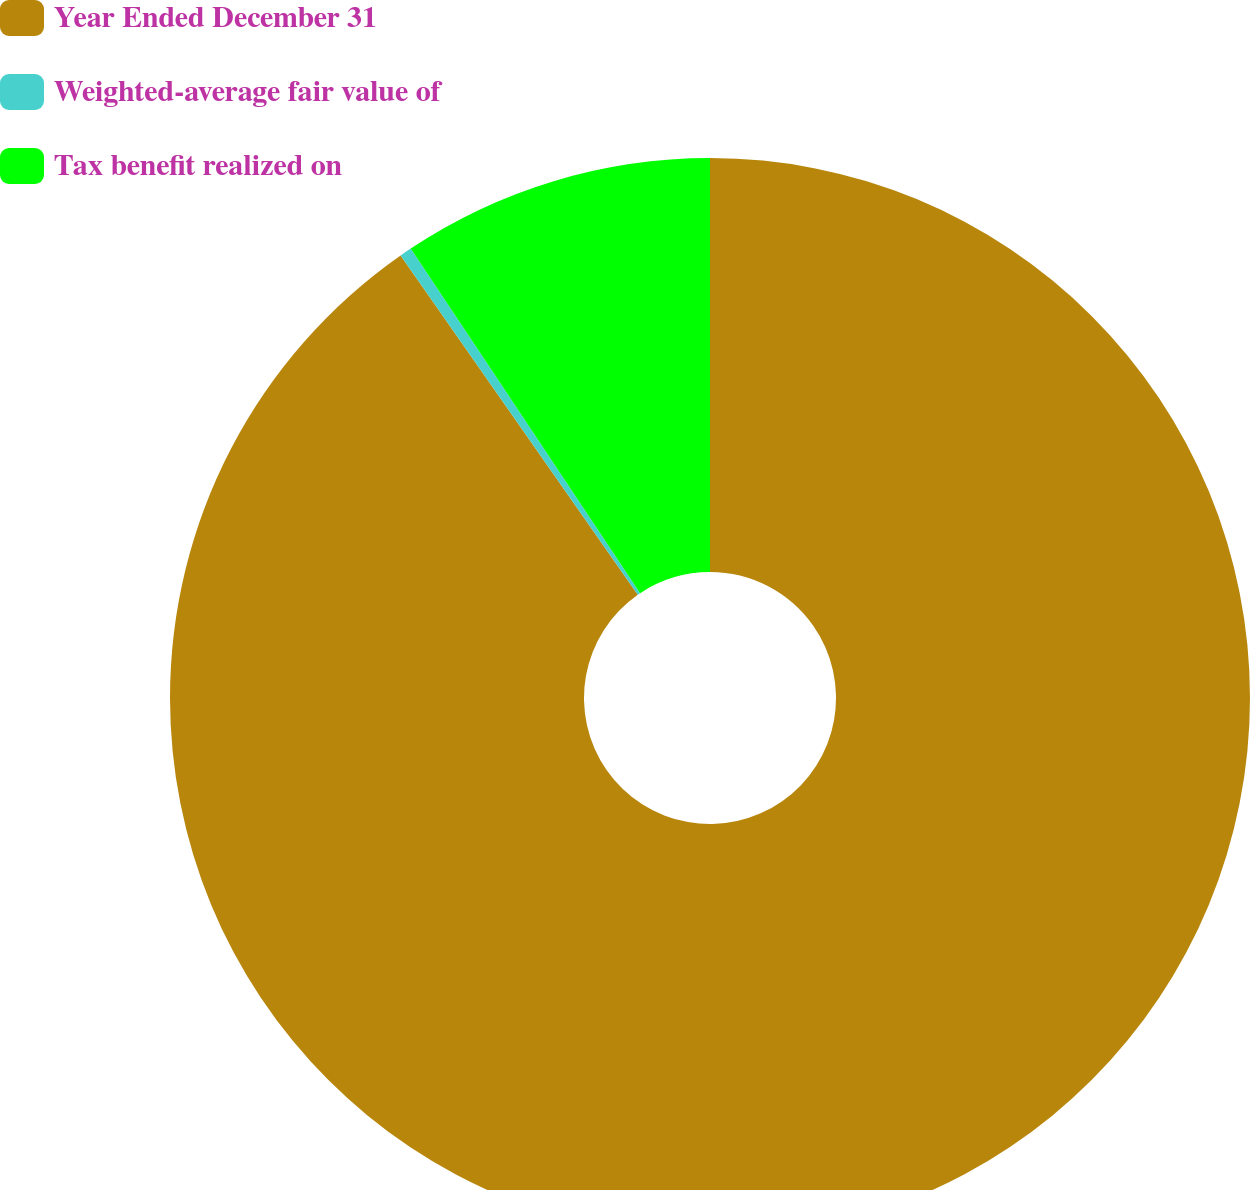<chart> <loc_0><loc_0><loc_500><loc_500><pie_chart><fcel>Year Ended December 31<fcel>Weighted-average fair value of<fcel>Tax benefit realized on<nl><fcel>90.29%<fcel>0.36%<fcel>9.35%<nl></chart> 